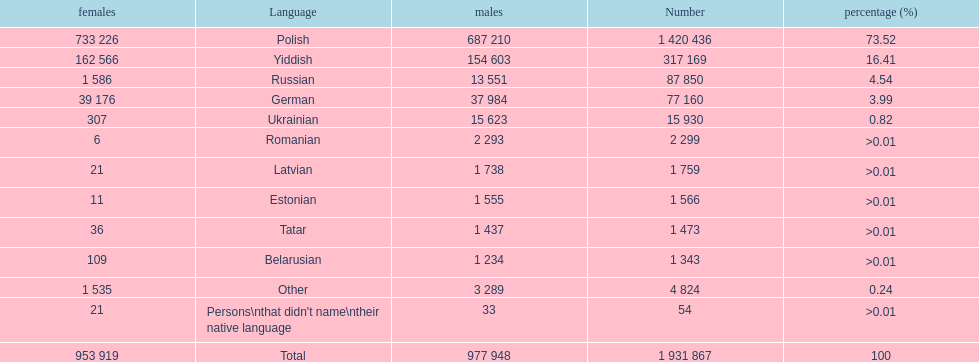Is german above or below russia in the number of people who speak that language? Below. 